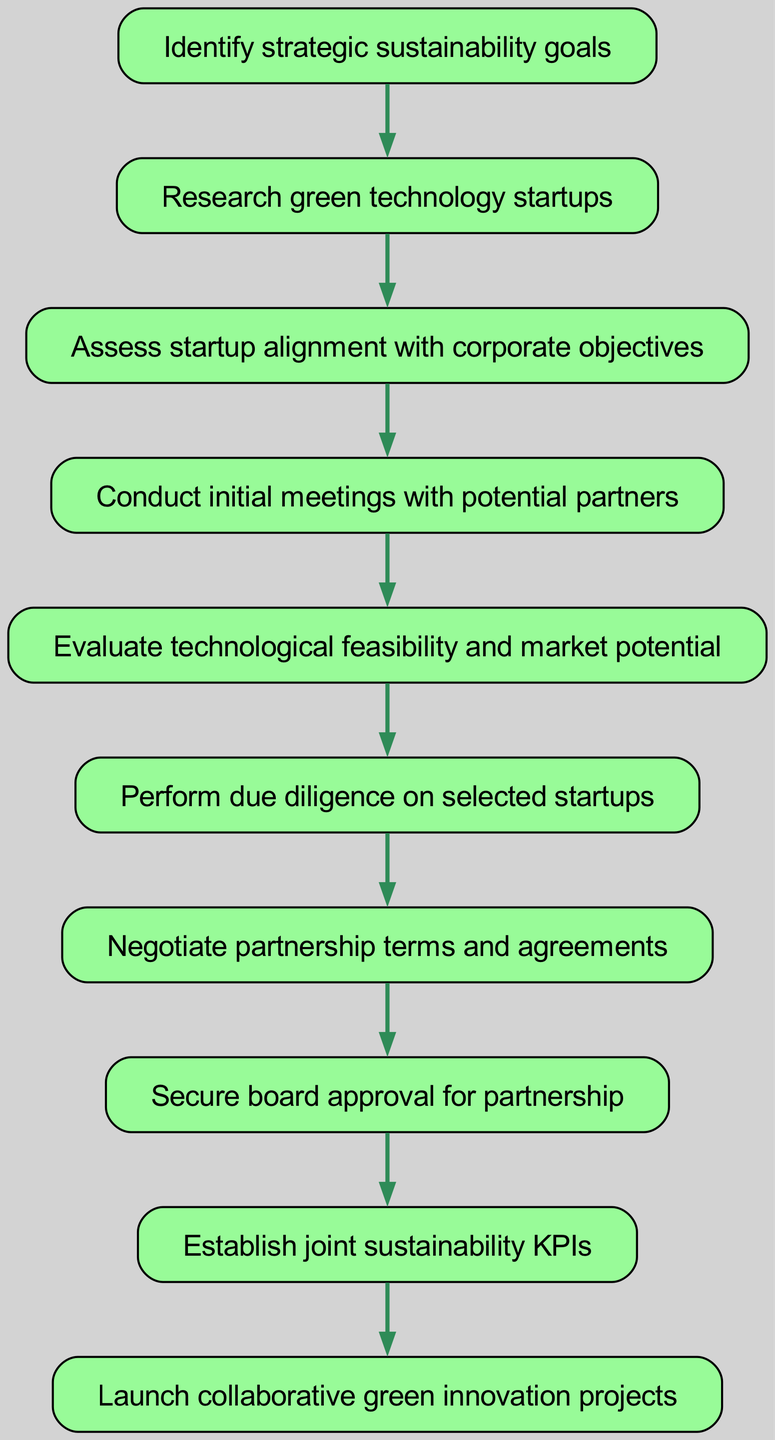What is the first step in establishing partnerships with green technology startups? The first step, as represented in the diagram, is to "Identify strategic sustainability goals". This is the starting point of the entire process.
Answer: Identify strategic sustainability goals How many nodes are in the diagram? Counting all the distinct steps outlined in the diagram, there are a total of 10 nodes representing different steps in the procedure.
Answer: 10 What is the last step to be executed in this flowchart? The final step in the chart, which would occur after all previous steps, is to "Launch collaborative green innovation projects". This is where the partnership culminates into actionable projects.
Answer: Launch collaborative green innovation projects What step comes after conducting initial meetings with potential partners? The step that follows conducting initial meetings is "Evaluate technological feasibility and market potential". This indicates a progression in the evaluation of potential partners.
Answer: Evaluate technological feasibility and market potential What is the relationship between assessing startup alignment and conducting initial meetings? The relationship is sequential; assessing startup alignment with corporate objectives must be completed before conducting initial meetings. This means we assess first to guide our meetings effectively.
Answer: Sequential relationship 